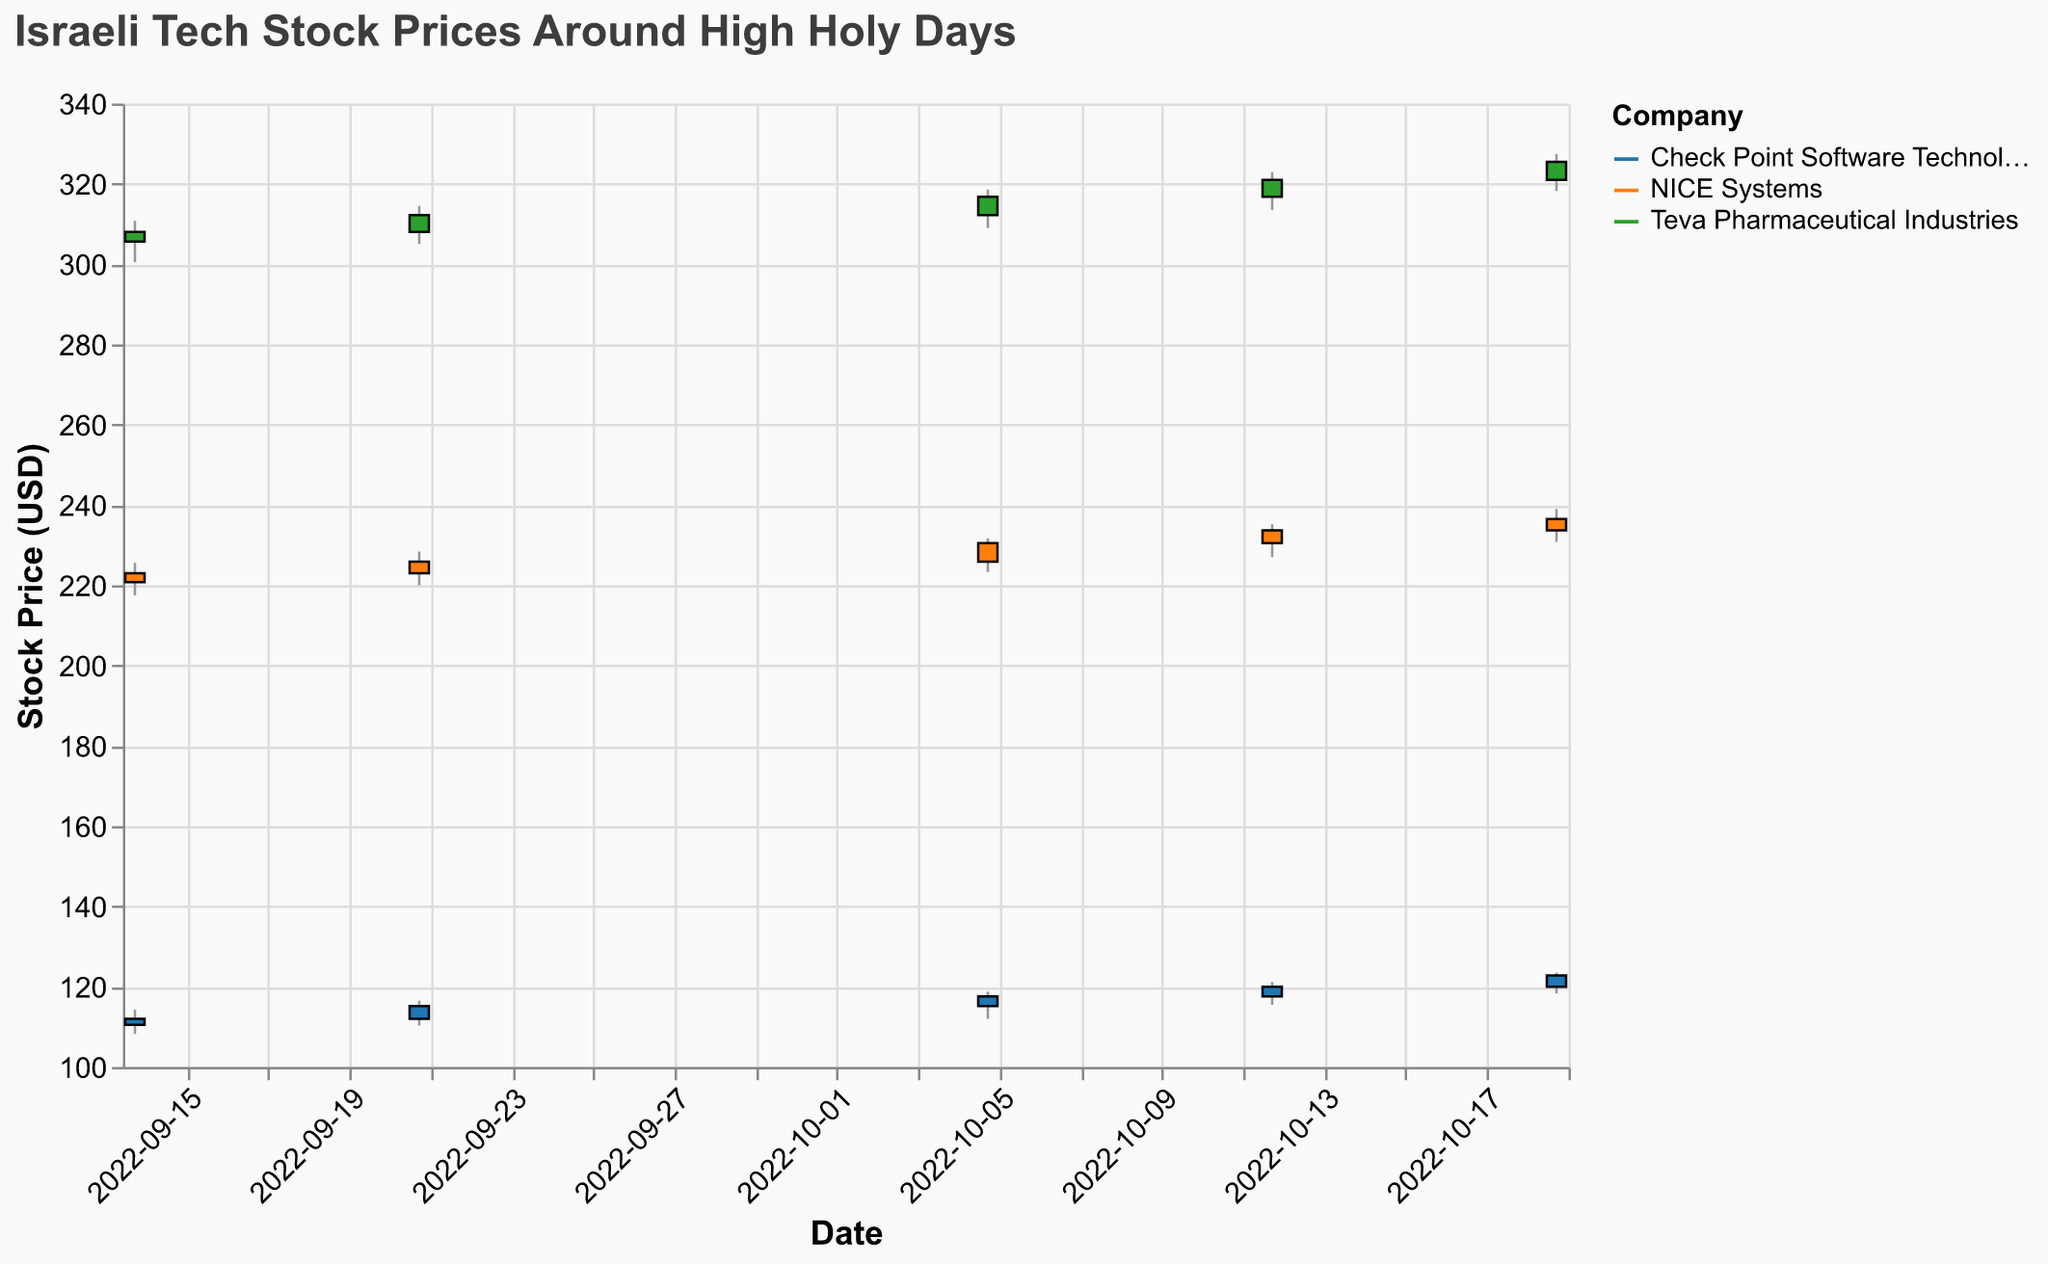Which company had the highest stock closing price on October 12, 2022? Look at the closing prices for each company on October 12, 2022. Compare them to identify the highest value.
Answer: Teva Pharmaceutical Industries Which company's stock showed the largest price range on October 19, 2022? Calculate the price range by subtracting the low price from the high price for each company on October 19, 2022. Compare the differences.
Answer: Teva Pharmaceutical Industries What was the percentage increase in Check Point Software Technologies' stock price from September 14 to October 19, 2022? Find the closing prices for Check Point Software Technologies on September 14 and October 19, then use the formula [(new - old) / old] * 100 to calculate the percentage increase.
Answer: (122.80 - 112.00) / 112.00 * 100 = 9.64% How did the trading volume for NICE Systems change from October 5 to October 19, 2022? Compare the trading volumes of NICE Systems on October 5 and October 19 by subtracting the earlier value from the later one.
Answer: 172000 - 165000 = 7000 Which company had the steadiest increase in stock price over the time period displayed? Examine the closing prices over the weeks for each company. Check the consistency of the increases week to week.
Answer: Teva Pharmaceutical Industries How many stocks showed an overall increase in price from September 14 to October 19, 2022? For each company, compare the closing prices on September 14 and October 19. Count how many showed an increase.
Answer: 3 Which company's stock had the smallest weekly price change during the period? Calculate the weekly price differences for each company, and identify the smallest among them.
Answer: Check Point Software Technologies Compare the opening prices of NICE Systems and Teva Pharmaceutical Industries on October 12, 2022, and identify which one was higher. Look at the opening prices of NICE Systems and Teva Pharmaceutical Industries on October 12 and compare them directly.
Answer: Teva Pharmaceutical Industries What was the highest single-day trading volume recorded, and which company had it? Compare the trading volumes listed for each date and identify the highest value.
Answer: NICE Systems on September 14, 2022 (175000) Calculate the total trading volume for Check Point Software Technologies over the entire period. Sum the trading volumes for Check Point Software Technologies for all listed dates.
Answer: 785000 